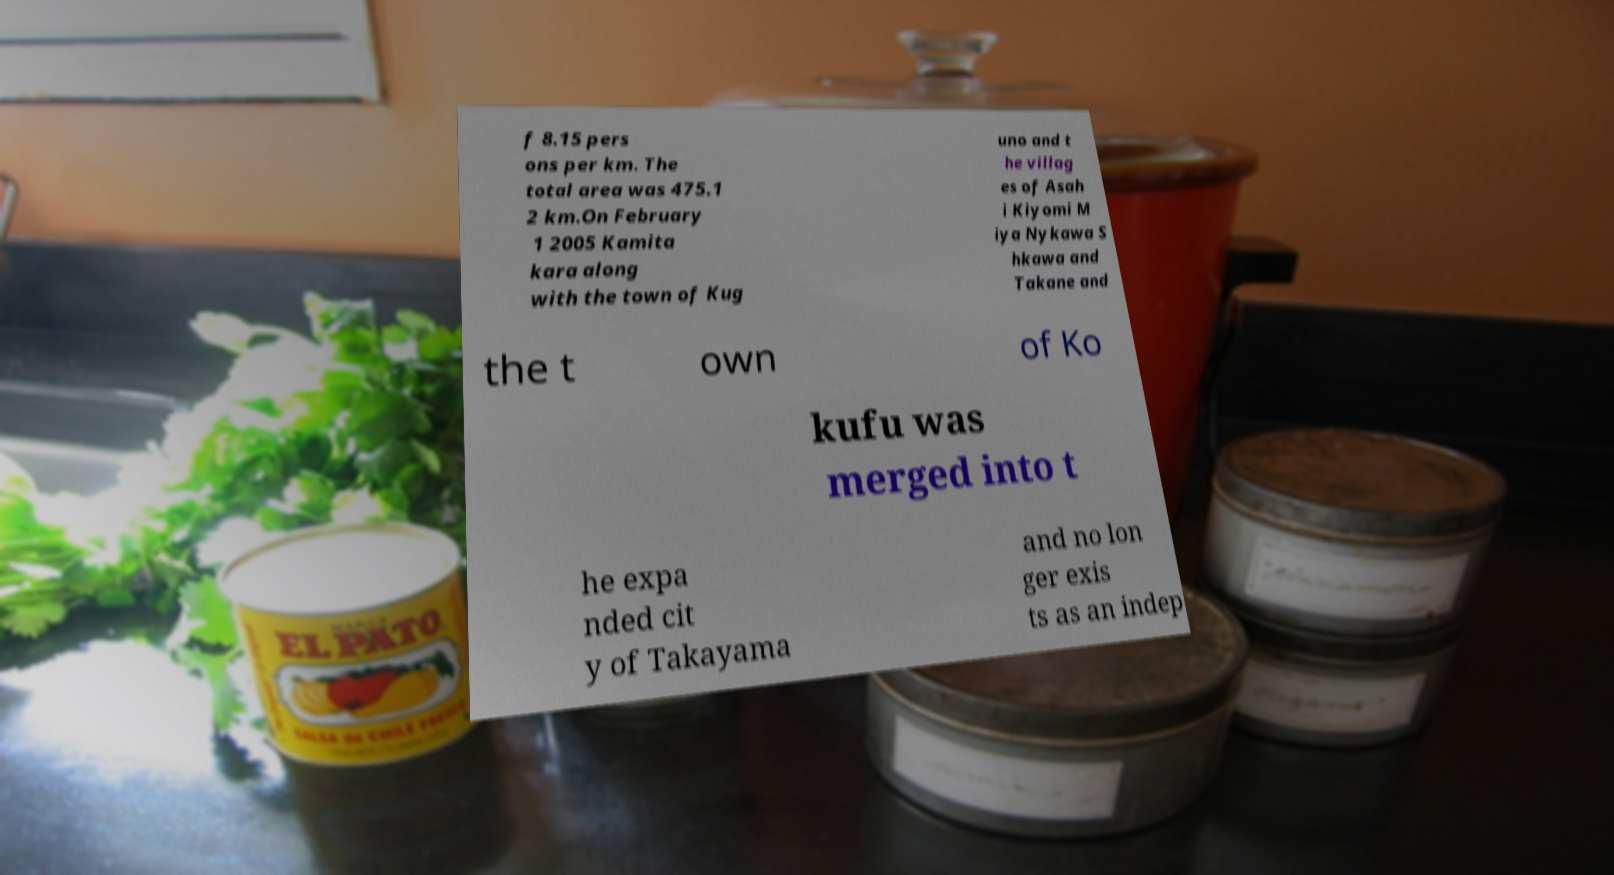Can you read and provide the text displayed in the image?This photo seems to have some interesting text. Can you extract and type it out for me? f 8.15 pers ons per km. The total area was 475.1 2 km.On February 1 2005 Kamita kara along with the town of Kug uno and t he villag es of Asah i Kiyomi M iya Nykawa S hkawa and Takane and the t own of Ko kufu was merged into t he expa nded cit y of Takayama and no lon ger exis ts as an indep 